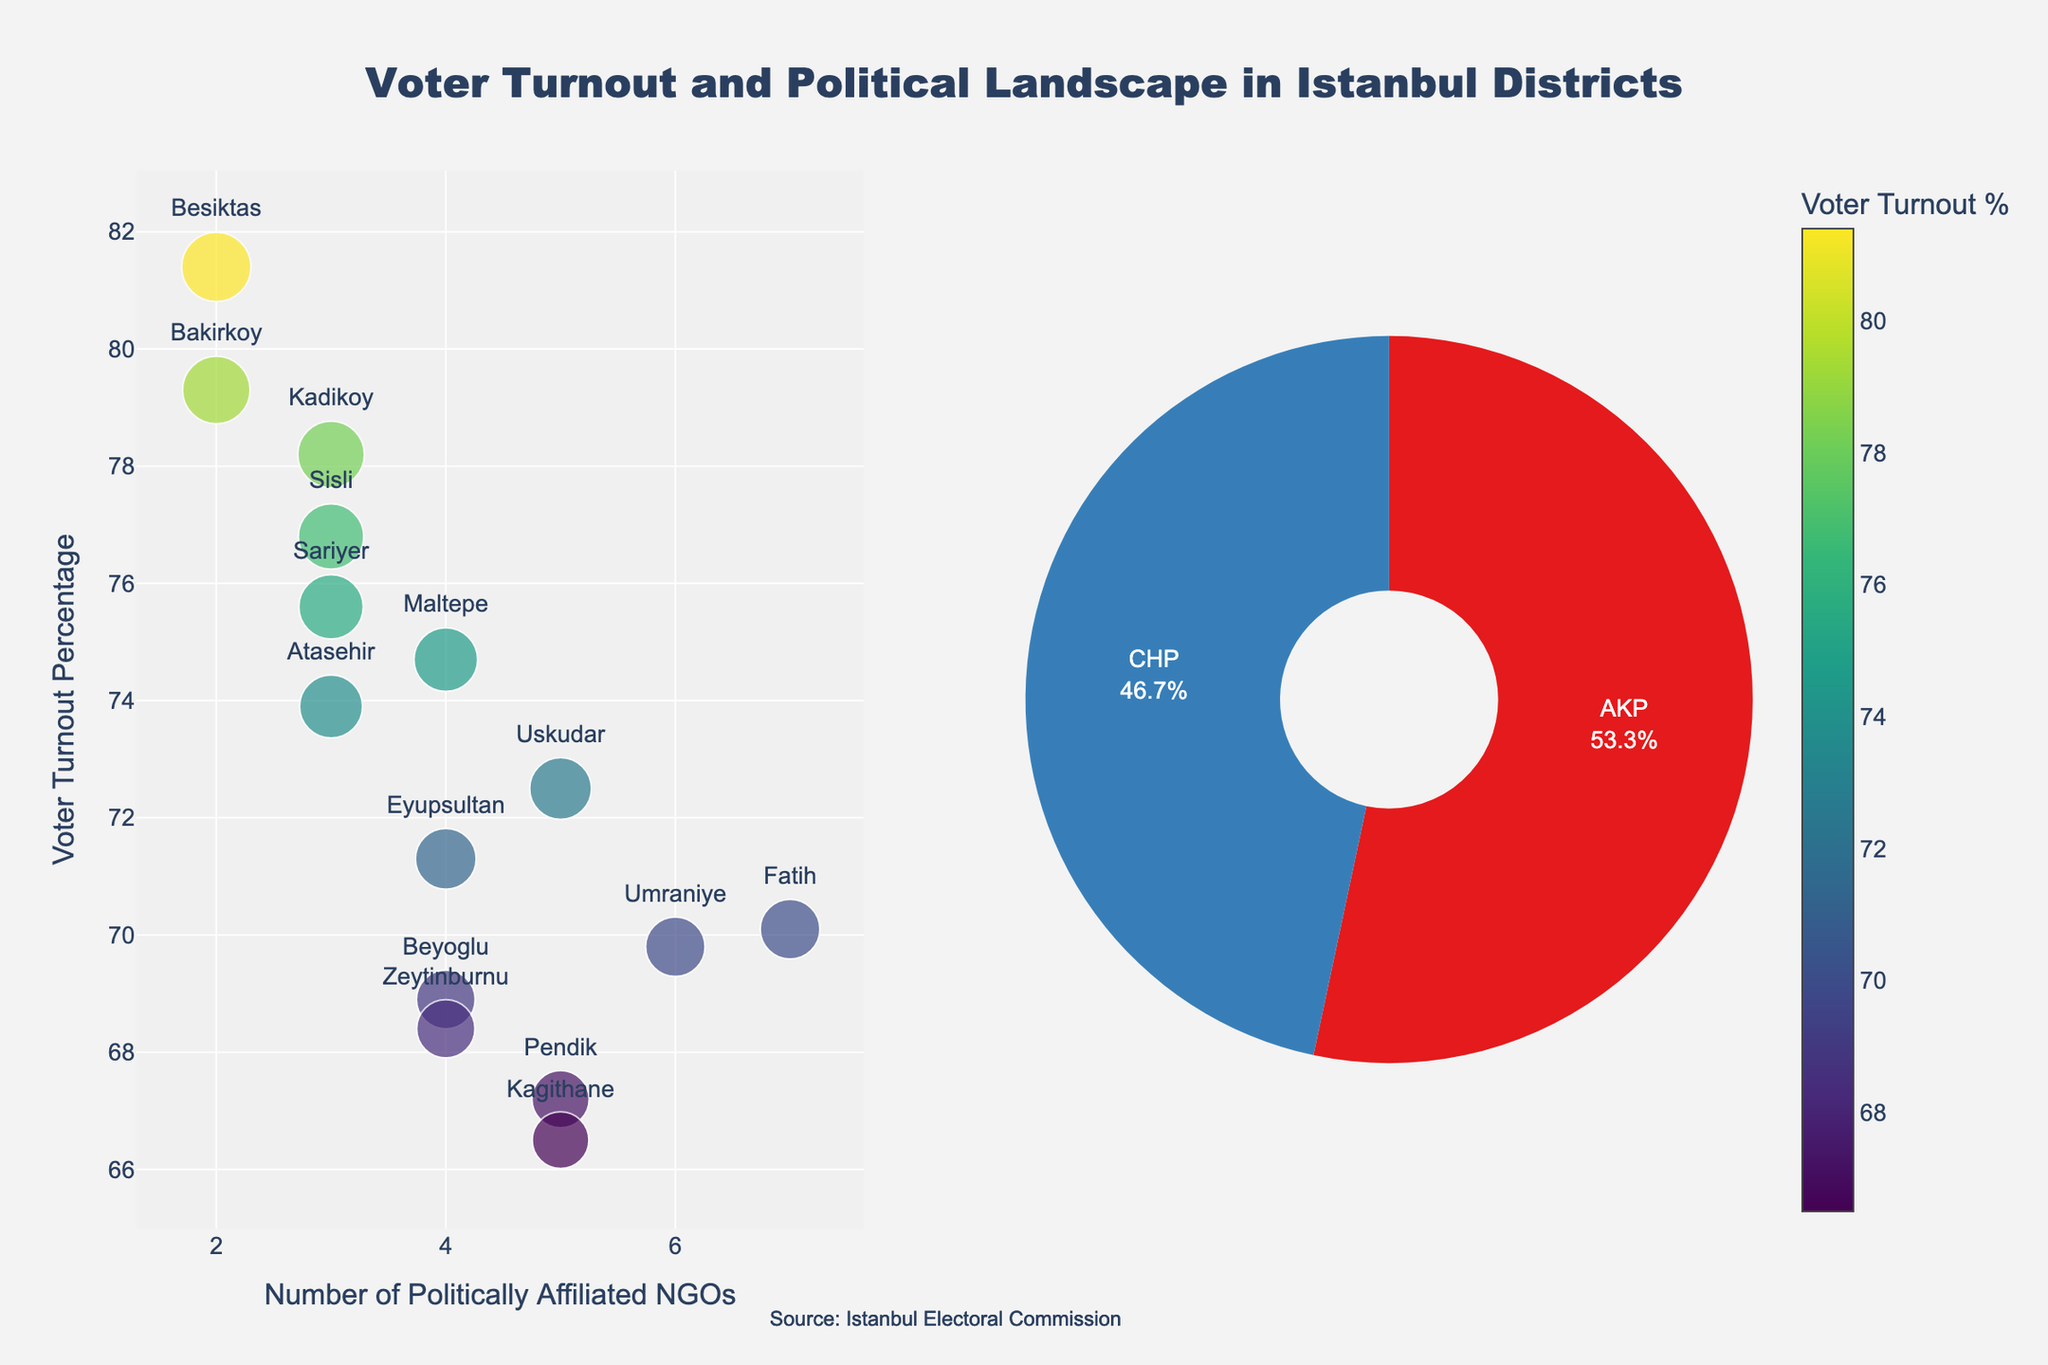What is the voter turnout percentage in Kadikoy? Refer to the scatter plot and find the data point labeled "Kadikoy". The text next to it shows the voter turnout percentage.
Answer: 78.2% How many districts have a dominant political affiliation with CHP? Look at the pie chart representing political affiliations. Count the number of sections labeled as CHP.
Answer: 7 What's the range of voter turnout percentages across all districts? Identify the highest and lowest voter turnout percentages on the scatter plot. The highest is around 81.4% and the lowest is 66.5%. Subtract the lowest from the highest: 81.4% - 66.5% = 14.9%.
Answer: 14.9% Which district has the highest number of politically-affiliated NGOs? Find the tallest bar in the scatter plot. The district with the highest number of NGOs is labeled next to this bar.
Answer: Fatih Do CHP-affiliated districts generally have higher or lower voter turnout compared to AKP-affiliated districts? Compare the average voter turnout in districts labeled as CHP and AKP in the scatter plot. CHP seems to have higher voter turnout percentages compared to AKP.
Answer: Higher How many districts have between 3 to 5 politically-affiliated NGOs? Observe the scatter plot and count the number of data points where the x-axis value (number of NGOs) lies between 3 and 5.
Answer: 8 Is there a correlation between the number of politically-affiliated NGOs and voter turnout? Look at the pattern in the scatter plot. Data points (districts) don't show a clear trend of increasing or decreasing voter turnout with the number of NGOs.
Answer: No clear correlation What voter turnout pattern is seen in districts affiliated with AKP? Check the scatter plot for districts labeled with AKP. They mostly lie below the 75% voter turnout mark.
Answer: Generally below 75% Which district has the lowest voter turnout percentage, and what is its dominant political affiliation? Locate the data point with the lowest voter turnout on the scatter plot and check its label and color pattern. The district is Kagithane.
Answer: Kagithane, AKP What's the average number of politically-affiliated NGOs in the districts dominated by CHP? Identify districts dominated by CHP from the pie chart. Sum their number of NGOs: (3 + 2 + 3 + 2 + 4 + 3 + 3) = 20. Then calculate the average: 20/7 = 2.86.
Answer: 2.86 